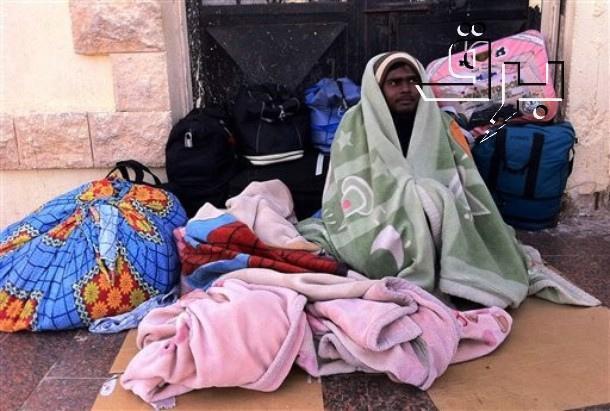How many backpacks are there?
Give a very brief answer. 3. 